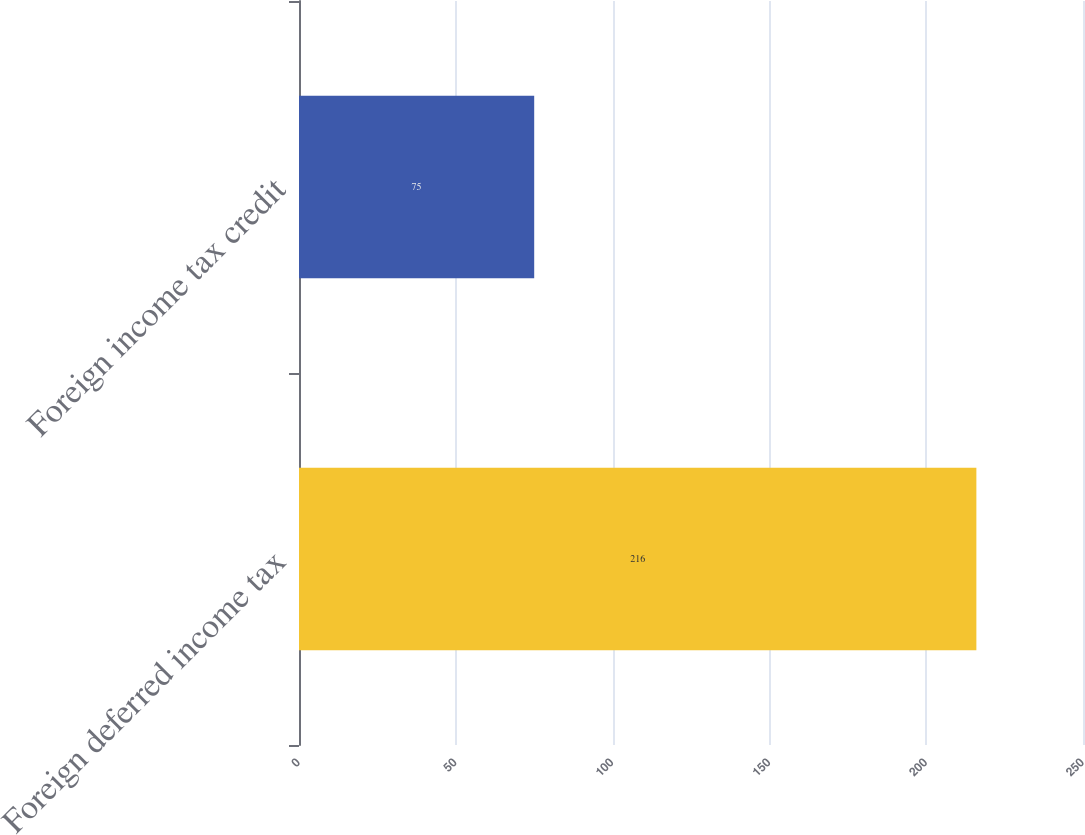Convert chart. <chart><loc_0><loc_0><loc_500><loc_500><bar_chart><fcel>Foreign deferred income tax<fcel>Foreign income tax credit<nl><fcel>216<fcel>75<nl></chart> 